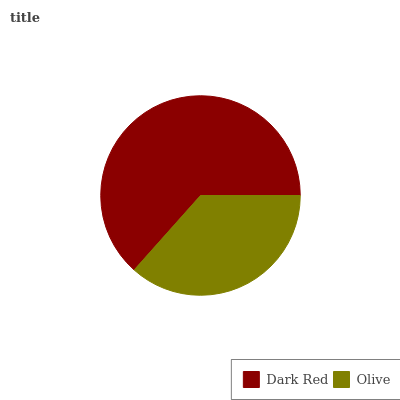Is Olive the minimum?
Answer yes or no. Yes. Is Dark Red the maximum?
Answer yes or no. Yes. Is Olive the maximum?
Answer yes or no. No. Is Dark Red greater than Olive?
Answer yes or no. Yes. Is Olive less than Dark Red?
Answer yes or no. Yes. Is Olive greater than Dark Red?
Answer yes or no. No. Is Dark Red less than Olive?
Answer yes or no. No. Is Dark Red the high median?
Answer yes or no. Yes. Is Olive the low median?
Answer yes or no. Yes. Is Olive the high median?
Answer yes or no. No. Is Dark Red the low median?
Answer yes or no. No. 